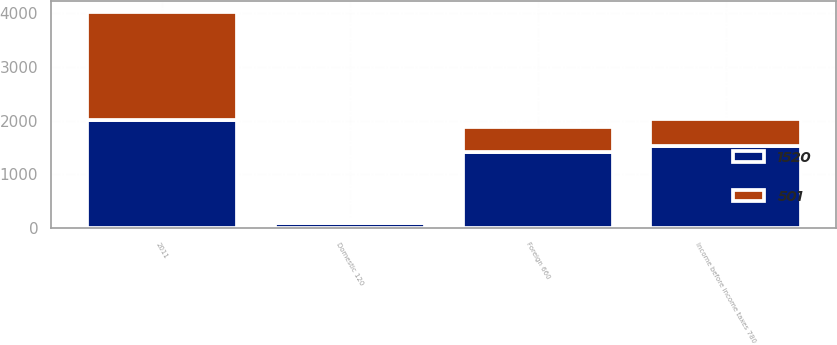<chart> <loc_0><loc_0><loc_500><loc_500><stacked_bar_chart><ecel><fcel>2011<fcel>Foreign 660<fcel>Domestic 120<fcel>Income before income taxes 780<nl><fcel>1520<fcel>2010<fcel>1418<fcel>102<fcel>1520<nl><fcel>501<fcel>2009<fcel>459<fcel>42<fcel>501<nl></chart> 